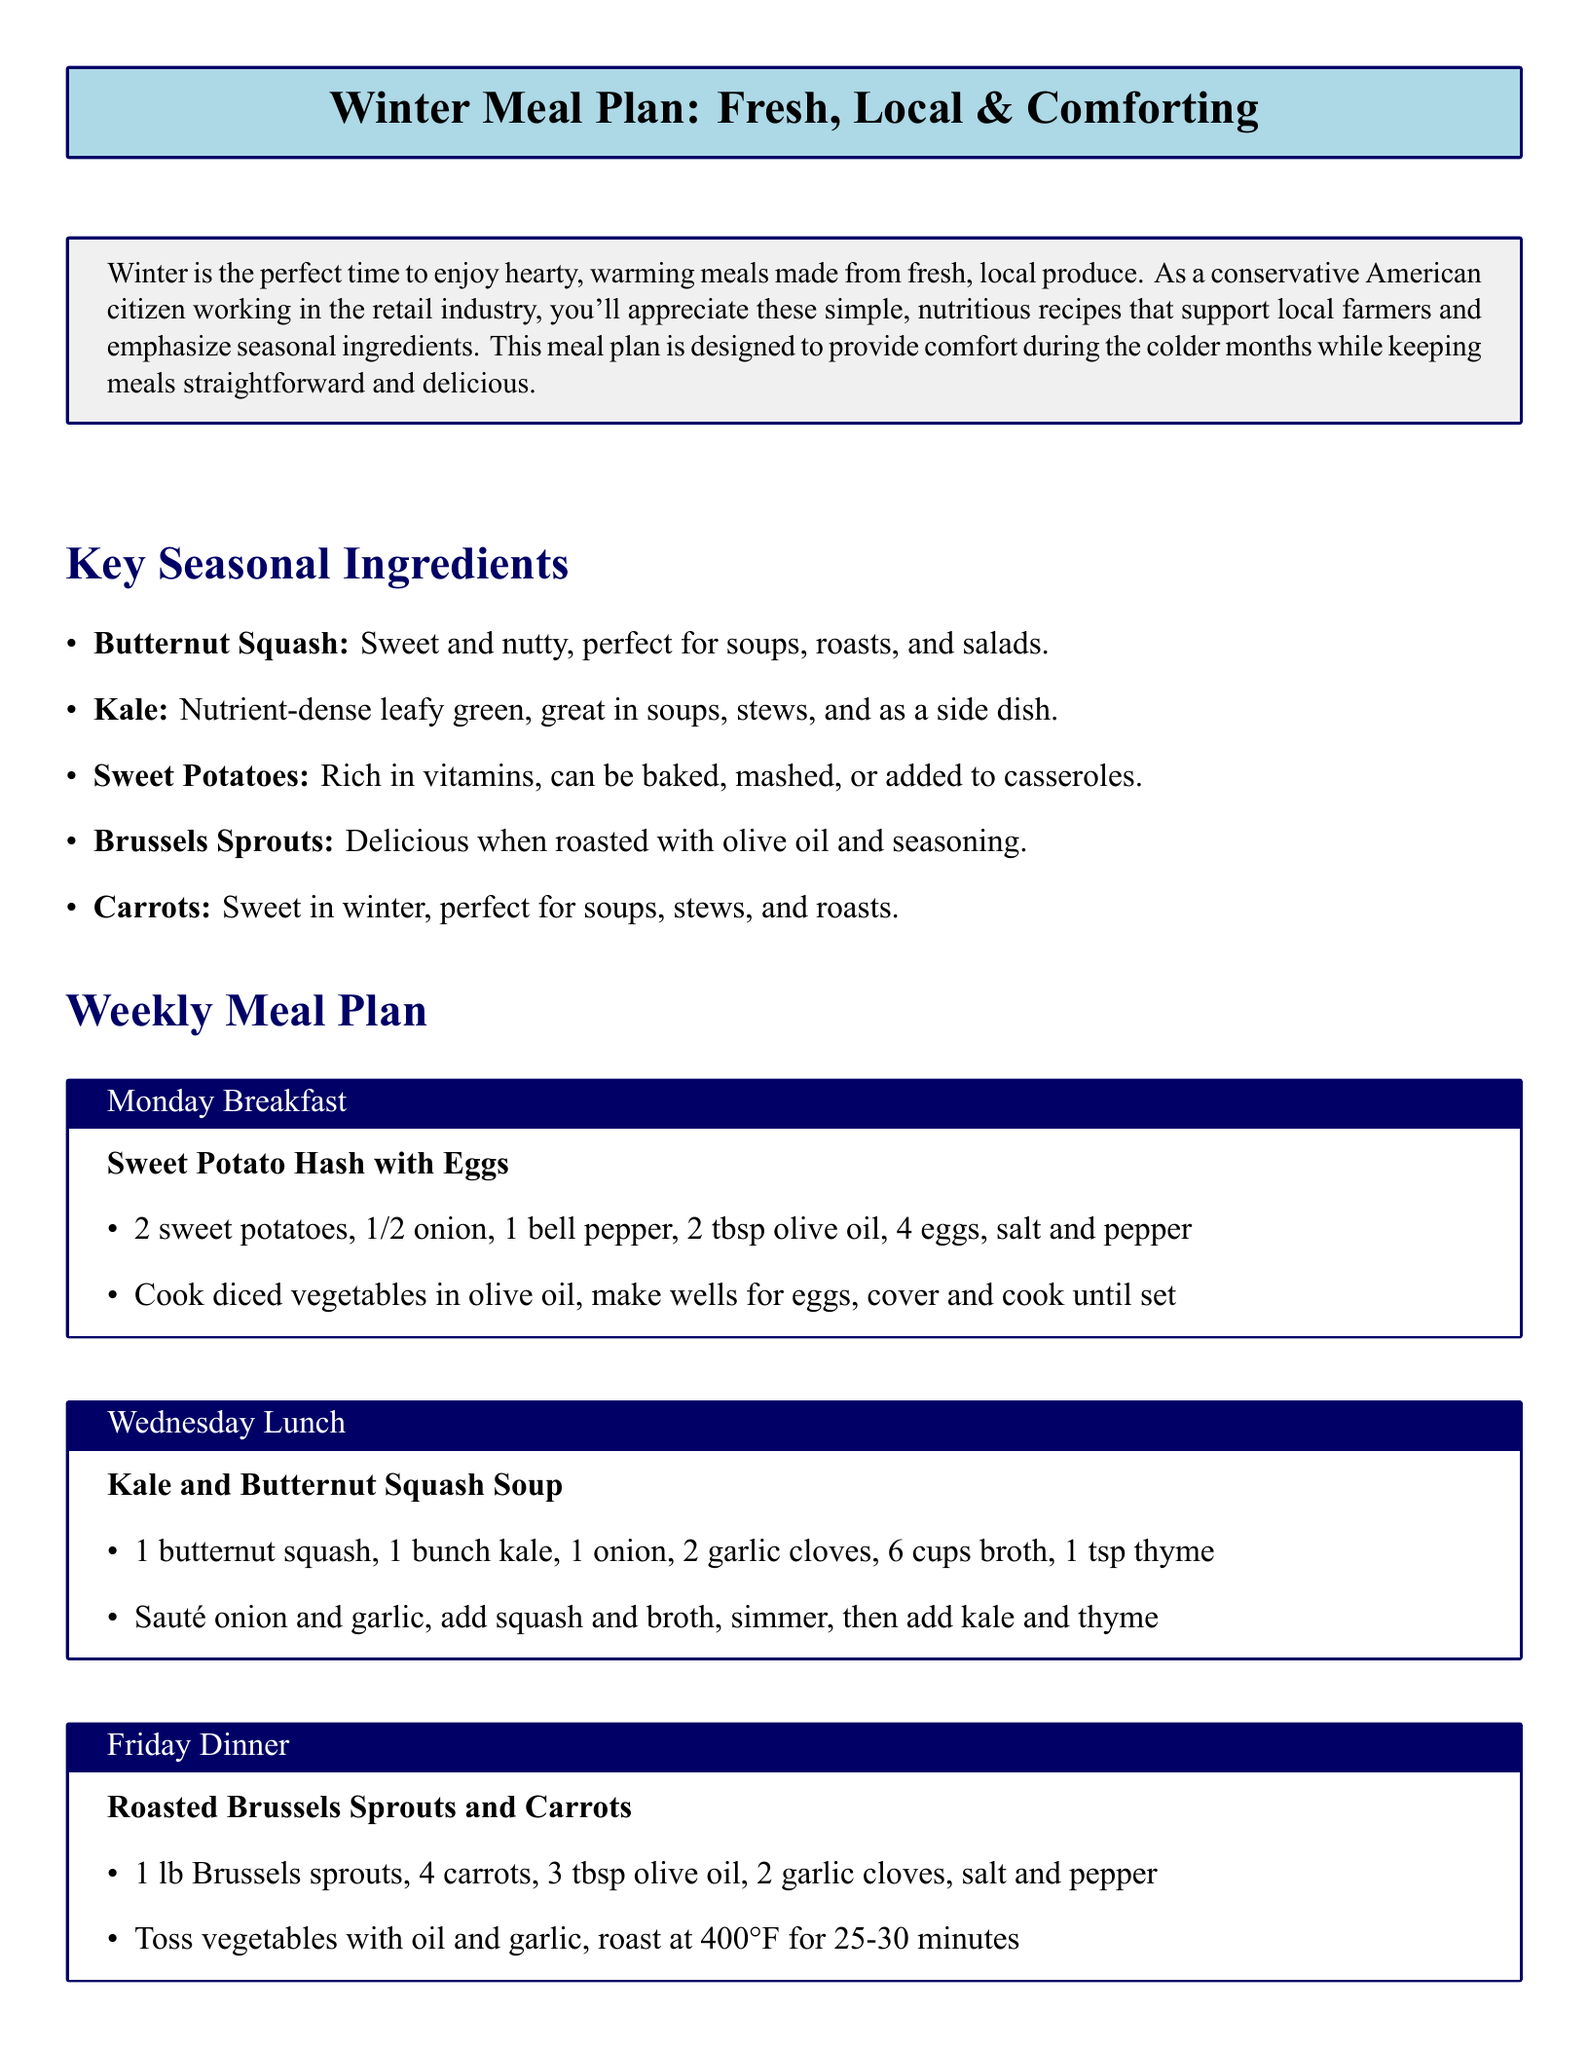What is the title of the meal plan? The title of the meal plan is presented in a large font at the top of the document.
Answer: Winter Meal Plan: Fresh, Local & Comforting Which vegetable is mentioned as sweet and nutty? The document lists butternut squash as sweet and nutty, suitable for various dishes.
Answer: Butternut Squash How many carrots are used in the Friday dinner recipe? The recipe for Friday dinner specifies using 4 carrots.
Answer: 4 What is a key ingredient in the Wednesday lunch recipe? The recipe for Wednesday lunch includes butternut squash and kale as key ingredients.
Answer: Butternut Squash What is the cooking temperature for the roasted vegetables? The document states that roasted Brussels sprouts and carrots should be cooked at 400°F.
Answer: 400°F Name one tip for meal prep mentioned in the document. The document provides tips for success, including prepping vegetables ahead of time.
Answer: Prep vegetables ahead What type of meal is served for Monday breakfast? The meal plan specifies Sweet Potato Hash with Eggs for Monday breakfast.
Answer: Sweet Potato Hash with Eggs How many cups of broth are in the kale and butternut squash soup? The recipe specifies using 6 cups of broth for the soup.
Answer: 6 cups Which dish incorporates kale? The document lists kale and butternut squash soup as a dish that incorporates kale.
Answer: Kale and Butternut Squash Soup 